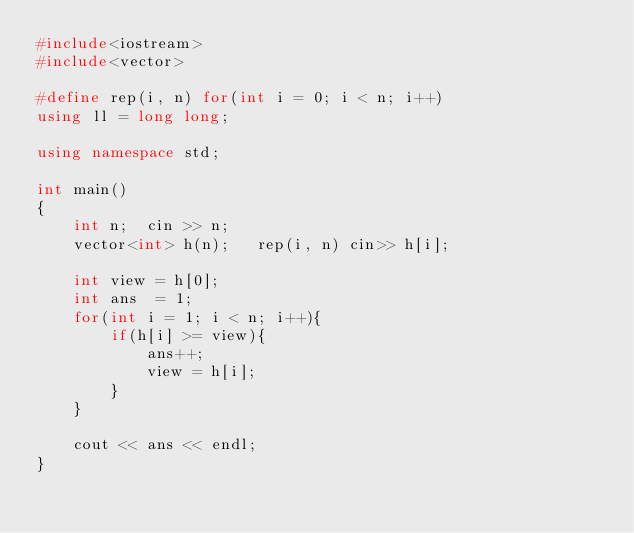<code> <loc_0><loc_0><loc_500><loc_500><_C++_>#include<iostream>
#include<vector>

#define rep(i, n) for(int i = 0; i < n; i++)
using ll = long long;

using namespace std;

int main()
{
    int n;  cin >> n;
    vector<int> h(n);   rep(i, n) cin>> h[i];

    int view = h[0];
    int ans  = 1;
    for(int i = 1; i < n; i++){
        if(h[i] >= view){
            ans++;
            view = h[i];
        }
    }

    cout << ans << endl;
}</code> 